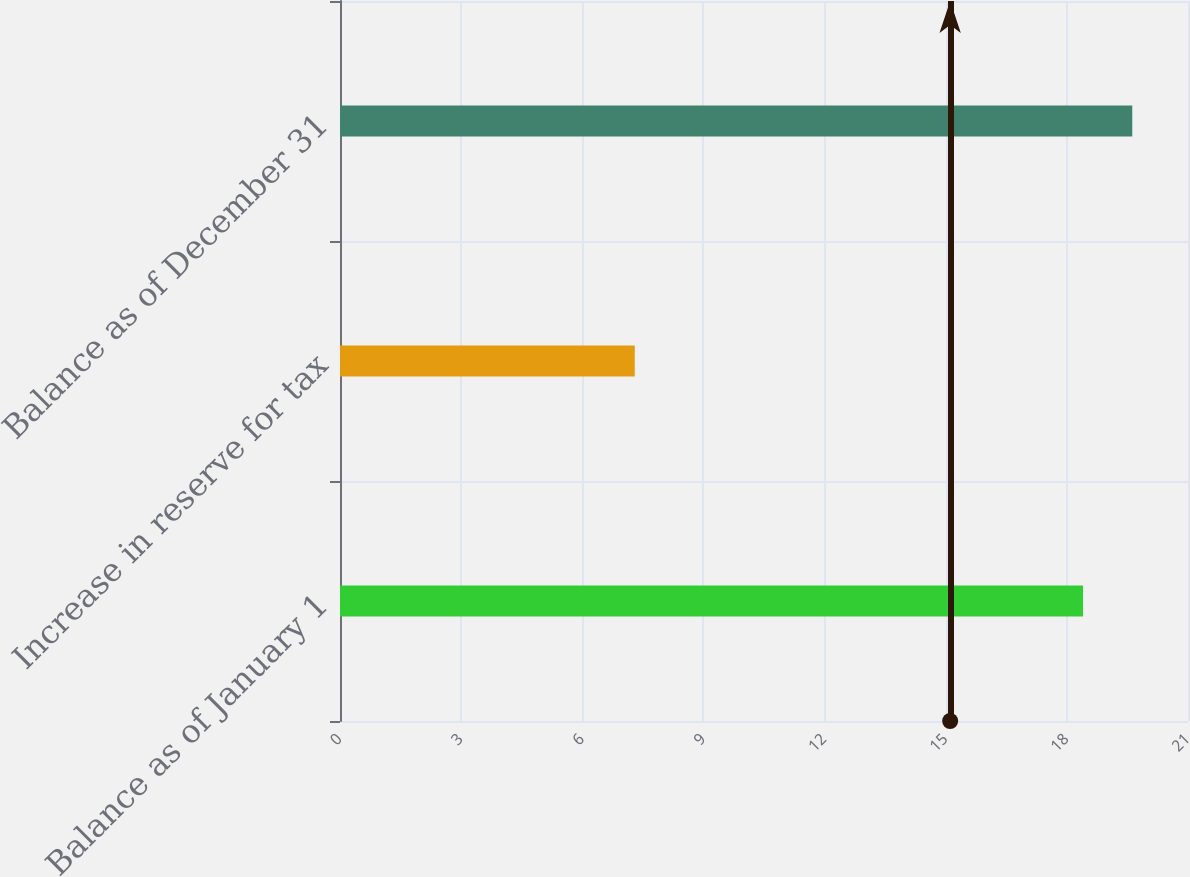<chart> <loc_0><loc_0><loc_500><loc_500><bar_chart><fcel>Balance as of January 1<fcel>Increase in reserve for tax<fcel>Balance as of December 31<nl><fcel>18.4<fcel>7.3<fcel>19.62<nl></chart> 